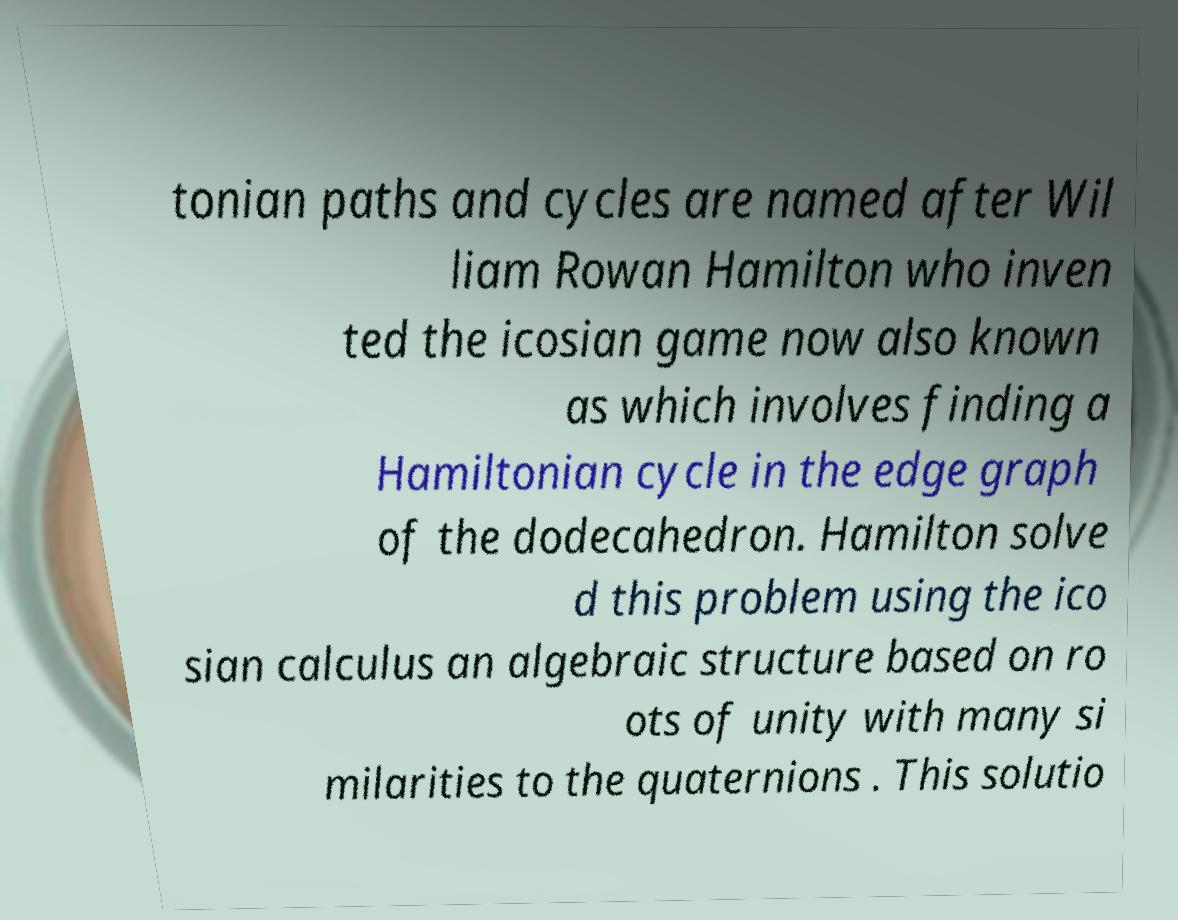For documentation purposes, I need the text within this image transcribed. Could you provide that? tonian paths and cycles are named after Wil liam Rowan Hamilton who inven ted the icosian game now also known as which involves finding a Hamiltonian cycle in the edge graph of the dodecahedron. Hamilton solve d this problem using the ico sian calculus an algebraic structure based on ro ots of unity with many si milarities to the quaternions . This solutio 